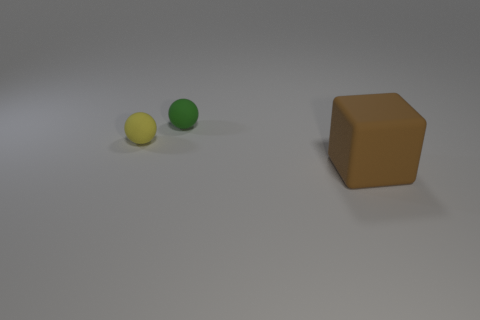What size is the matte thing that is right of the yellow matte sphere and in front of the small green sphere?
Ensure brevity in your answer.  Large. There is another thing that is the same size as the yellow thing; what is its shape?
Keep it short and to the point. Sphere. There is another thing that is the same shape as the tiny green object; what is its color?
Your response must be concise. Yellow. What number of things are green cylinders or small matte spheres?
Provide a succinct answer. 2. There is a small matte object that is in front of the small green ball; is its shape the same as the tiny thing that is right of the yellow ball?
Keep it short and to the point. Yes. What shape is the big rubber thing right of the green rubber object?
Offer a very short reply. Cube. Are there an equal number of yellow things behind the yellow matte sphere and tiny spheres on the left side of the big brown block?
Keep it short and to the point. No. What number of objects are yellow objects or matte objects that are left of the large brown matte cube?
Offer a very short reply. 2. What shape is the matte thing that is both to the left of the large brown thing and to the right of the yellow matte ball?
Keep it short and to the point. Sphere. What size is the matte thing that is on the right side of the tiny green sphere?
Provide a succinct answer. Large. 